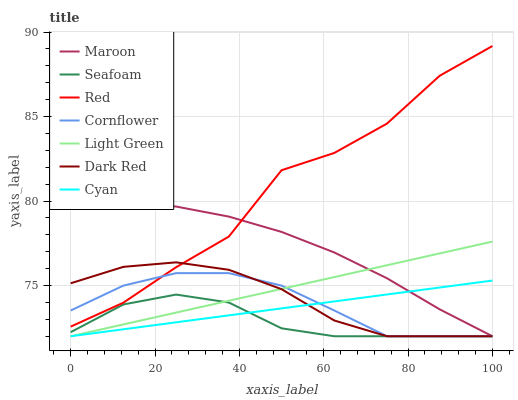Does Dark Red have the minimum area under the curve?
Answer yes or no. No. Does Dark Red have the maximum area under the curve?
Answer yes or no. No. Is Dark Red the smoothest?
Answer yes or no. No. Is Dark Red the roughest?
Answer yes or no. No. Does Red have the lowest value?
Answer yes or no. No. Does Dark Red have the highest value?
Answer yes or no. No. Is Light Green less than Red?
Answer yes or no. Yes. Is Red greater than Light Green?
Answer yes or no. Yes. Does Light Green intersect Red?
Answer yes or no. No. 